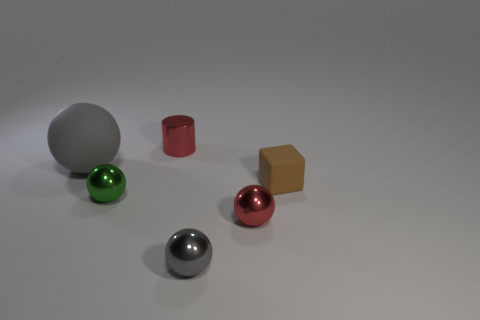Can you describe the shapes and colors of the objects in the image? Certainly. The image displays a collection of six objects with various shapes and colors. There's a grey sphere, a green sphere, and a red sphere, as well as a silver metal cylinder, a gold cube, and a red cylinder. 